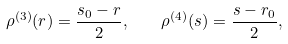Convert formula to latex. <formula><loc_0><loc_0><loc_500><loc_500>\rho ^ { ( 3 ) } ( r ) = \frac { s _ { 0 } - r } { 2 } , \quad \rho ^ { ( 4 ) } ( s ) = \frac { s - r _ { 0 } } { 2 } ,</formula> 